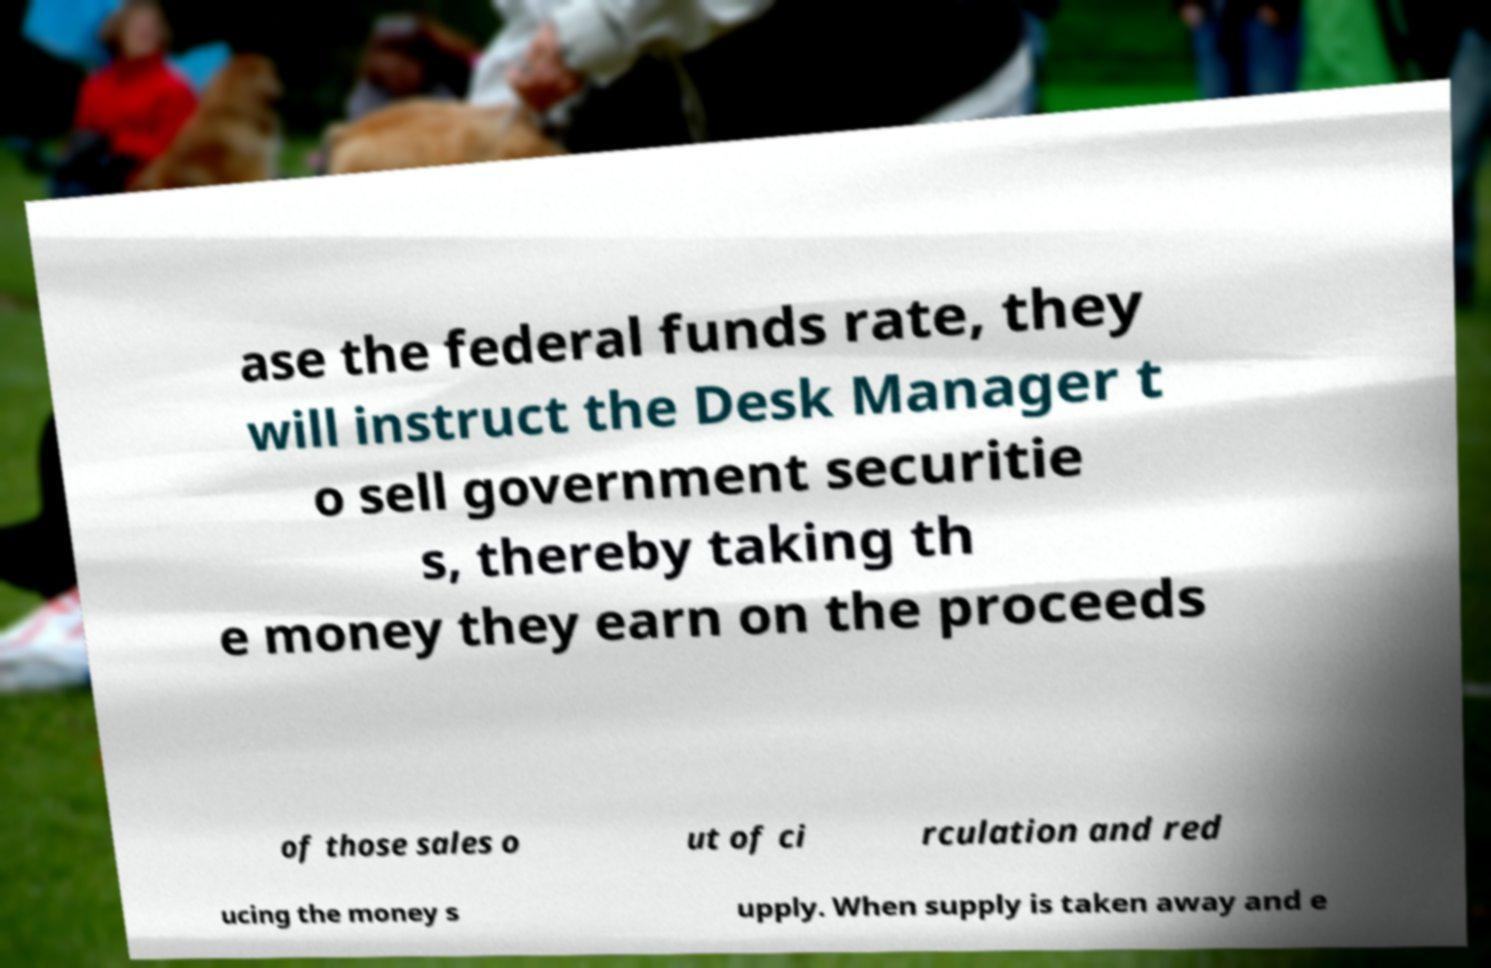For documentation purposes, I need the text within this image transcribed. Could you provide that? ase the federal funds rate, they will instruct the Desk Manager t o sell government securitie s, thereby taking th e money they earn on the proceeds of those sales o ut of ci rculation and red ucing the money s upply. When supply is taken away and e 